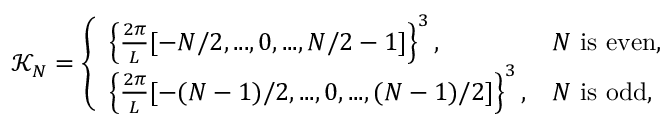Convert formula to latex. <formula><loc_0><loc_0><loc_500><loc_500>\mathcal { K } _ { N } = \left \{ \begin{array} { l l } { \left \{ \frac { 2 \pi } { L } [ - N / 2 , \dots , 0 , \dots , N / 2 - 1 ] \right \} ^ { 3 } , } & { N i s e v e n , } \\ { \left \{ \frac { 2 \pi } { L } [ - ( N - 1 ) / 2 , \dots , 0 , \dots , ( N - 1 ) / 2 ] \right \} ^ { 3 } , } & { N i s o d d , } \end{array}</formula> 